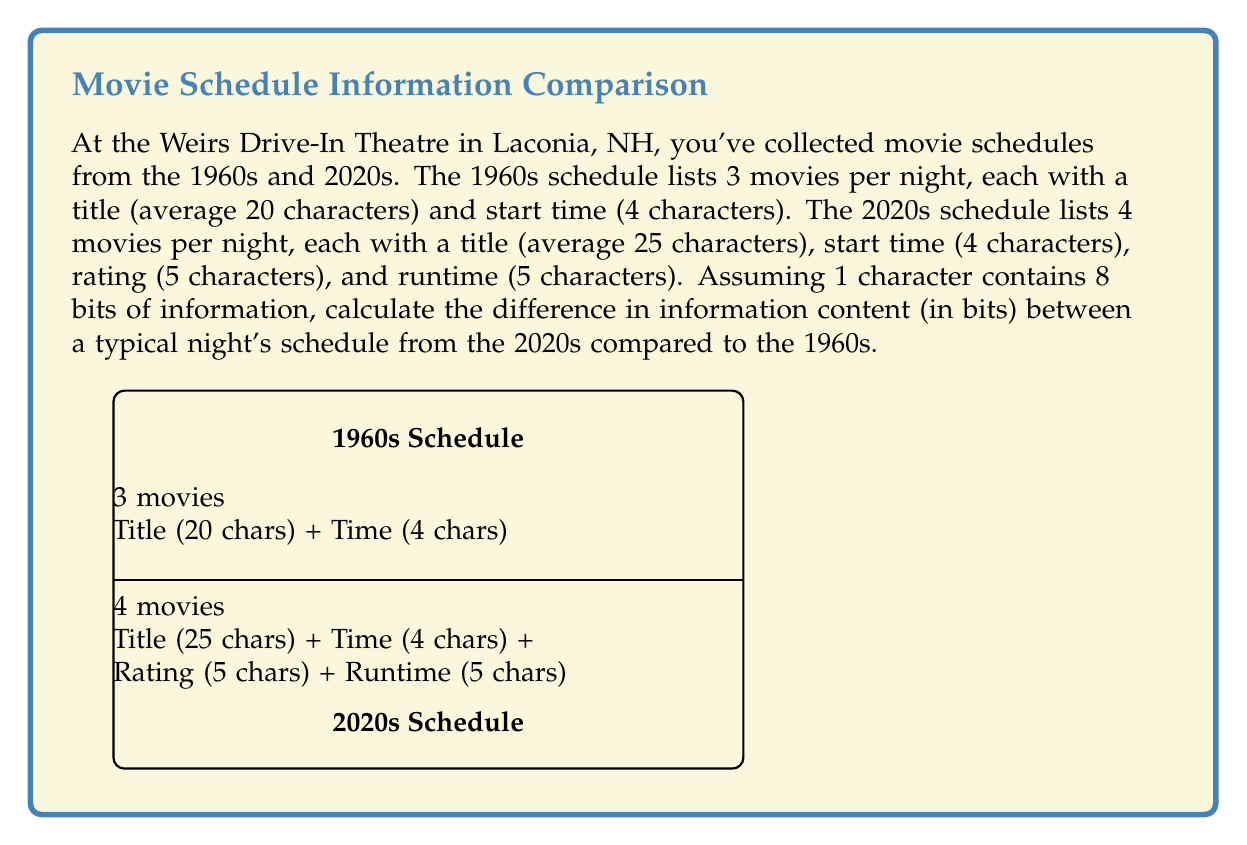Solve this math problem. Let's break this down step-by-step:

1) First, calculate the information content of a 1960s schedule:
   - Each movie has: 20 (title) + 4 (time) = 24 characters
   - There are 3 movies per night
   - Total characters: $24 \times 3 = 72$ characters
   - Information content: $72 \times 8 = 576$ bits

2) Now, calculate the information content of a 2020s schedule:
   - Each movie has: 25 (title) + 4 (time) + 5 (rating) + 5 (runtime) = 39 characters
   - There are 4 movies per night
   - Total characters: $39 \times 4 = 156$ characters
   - Information content: $156 \times 8 = 1248$ bits

3) Calculate the difference:
   $1248 - 576 = 672$ bits

Therefore, a typical night's schedule from the 2020s contains 672 more bits of information than a schedule from the 1960s.
Answer: 672 bits 